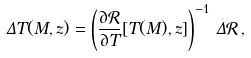Convert formula to latex. <formula><loc_0><loc_0><loc_500><loc_500>\Delta T ( M , z ) = \left ( \frac { \partial \mathcal { R } } { \partial T } [ T ( M ) , z ] \right ) ^ { - 1 } \, \Delta \mathcal { R } \, ,</formula> 